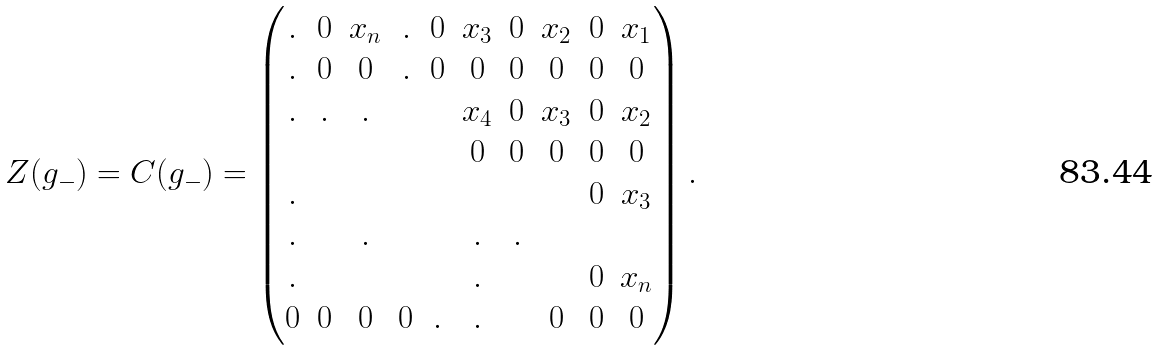<formula> <loc_0><loc_0><loc_500><loc_500>Z ( g _ { - } ) = C ( g _ { - } ) = \left ( \begin{matrix} . & 0 & x _ { n } & . & 0 & x _ { 3 } & 0 & x _ { 2 } & 0 & x _ { 1 } \\ . & 0 & 0 & . & 0 & 0 & 0 & 0 & 0 & 0 \\ . & . & . & & & x _ { 4 } & 0 & x _ { 3 } & 0 & x _ { 2 } \\ & & & & & 0 & 0 & 0 & 0 & 0 \\ . & & & & & & & & 0 & x _ { 3 } \\ . & & . & & & . & . \\ . & & & & & . & & & 0 & x _ { n } \\ 0 & 0 & 0 & 0 & . & . & & 0 & 0 & 0 \end{matrix} \right ) .</formula> 